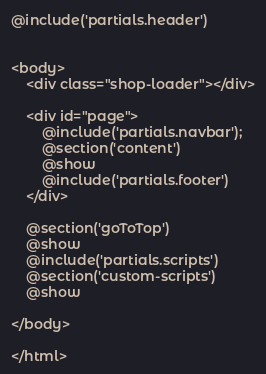<code> <loc_0><loc_0><loc_500><loc_500><_PHP_>@include('partials.header')


<body>
    <div class="shop-loader"></div>

    <div id="page">
        @include('partials.navbar');
        @section('content')
        @show
        @include('partials.footer')
    </div>

    @section('goToTop')
    @show
    @include('partials.scripts')
    @section('custom-scripts')
    @show

</body>

</html>
</code> 